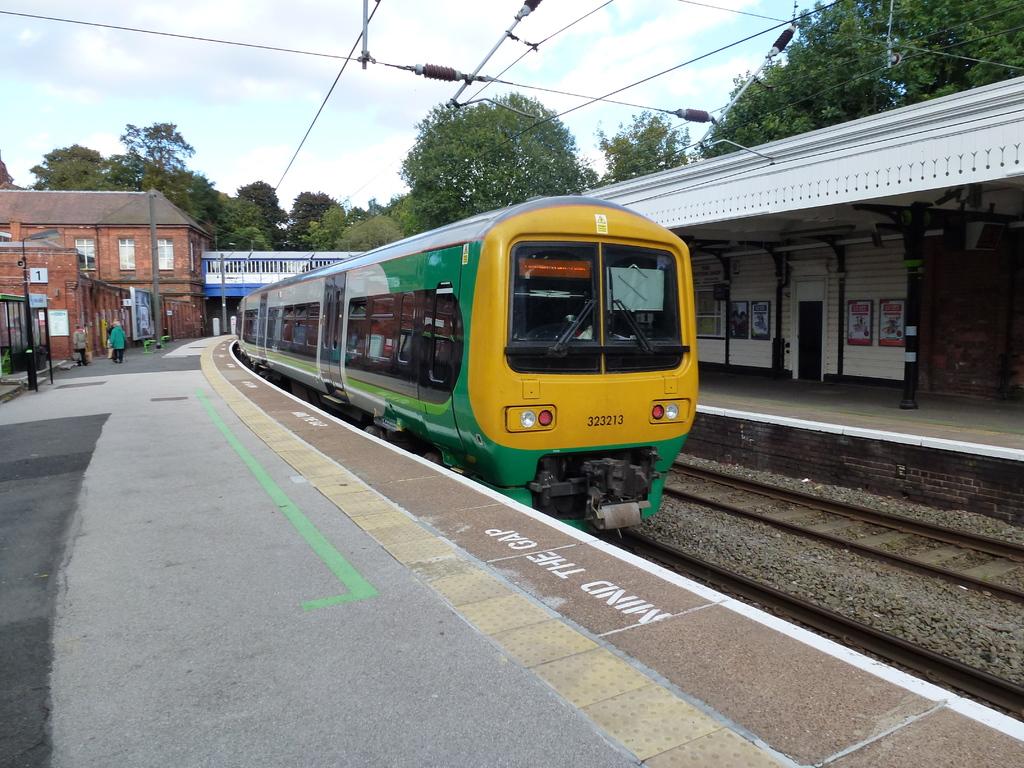What is the train number?
Your answer should be very brief. 323213. What should you mind?
Provide a short and direct response. The gap. 